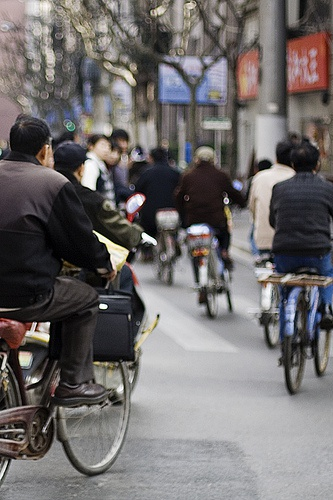Describe the objects in this image and their specific colors. I can see people in darkgray, black, and gray tones, bicycle in darkgray, black, gray, and maroon tones, people in darkgray, black, gray, and darkblue tones, people in darkgray, black, gray, and darkgreen tones, and bicycle in darkgray, black, and gray tones in this image. 